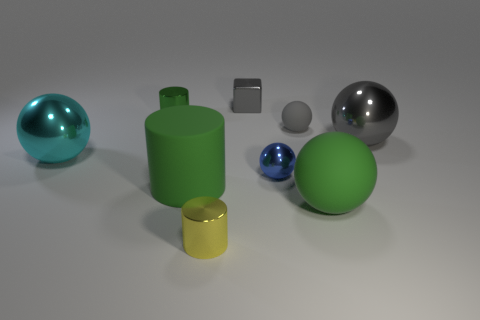Subtract all green balls. How many balls are left? 4 Subtract 1 spheres. How many spheres are left? 4 Subtract all yellow balls. Subtract all cyan cylinders. How many balls are left? 5 Add 1 large green matte cylinders. How many objects exist? 10 Subtract all spheres. How many objects are left? 4 Add 7 purple cylinders. How many purple cylinders exist? 7 Subtract 1 yellow cylinders. How many objects are left? 8 Subtract all large cyan metal spheres. Subtract all gray rubber balls. How many objects are left? 7 Add 3 small balls. How many small balls are left? 5 